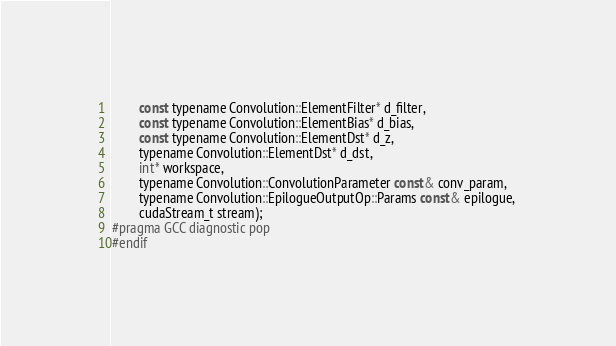Convert code to text. <code><loc_0><loc_0><loc_500><loc_500><_Cuda_>        const typename Convolution::ElementFilter* d_filter, 
        const typename Convolution::ElementBias* d_bias, 
        const typename Convolution::ElementDst* d_z, 
        typename Convolution::ElementDst* d_dst, 
        int* workspace, 
        typename Convolution::ConvolutionParameter const& conv_param, 
        typename Convolution::EpilogueOutputOp::Params const& epilogue, 
        cudaStream_t stream);
#pragma GCC diagnostic pop
#endif
</code> 